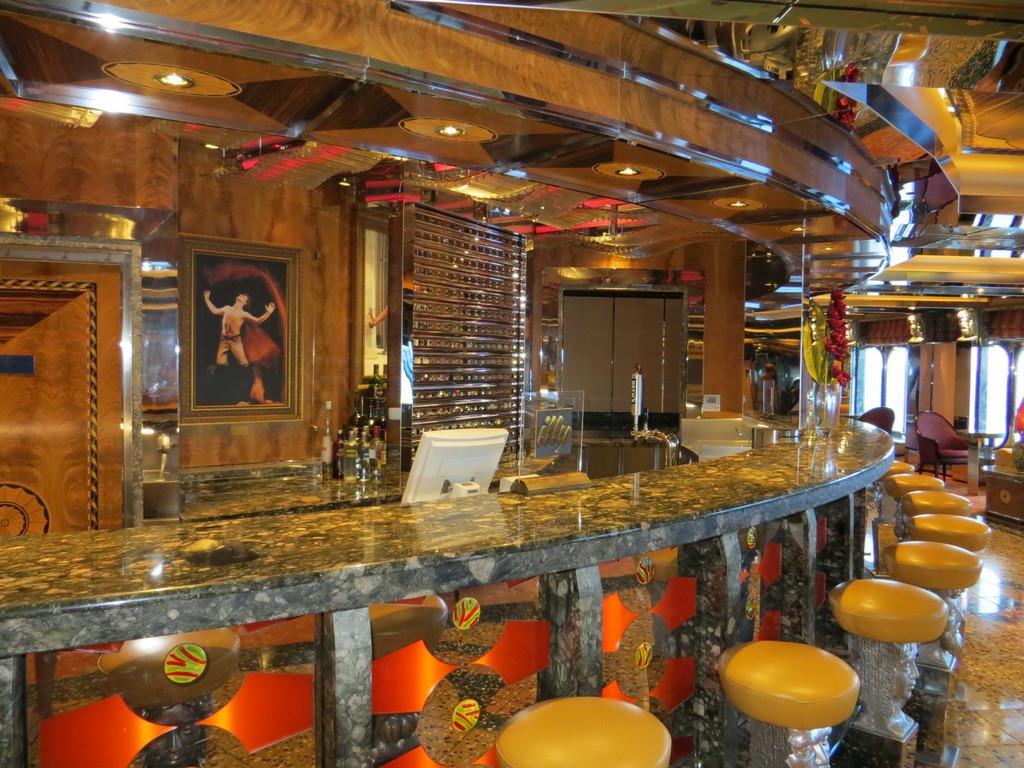Can you describe this image briefly? In this image we can see a countertop and stools. At the top of the image, we can see the roof and lights. On the right side of the image, we can see the chairs. In the background, we can see bottles, monitor, frame on the wall and some objects. 